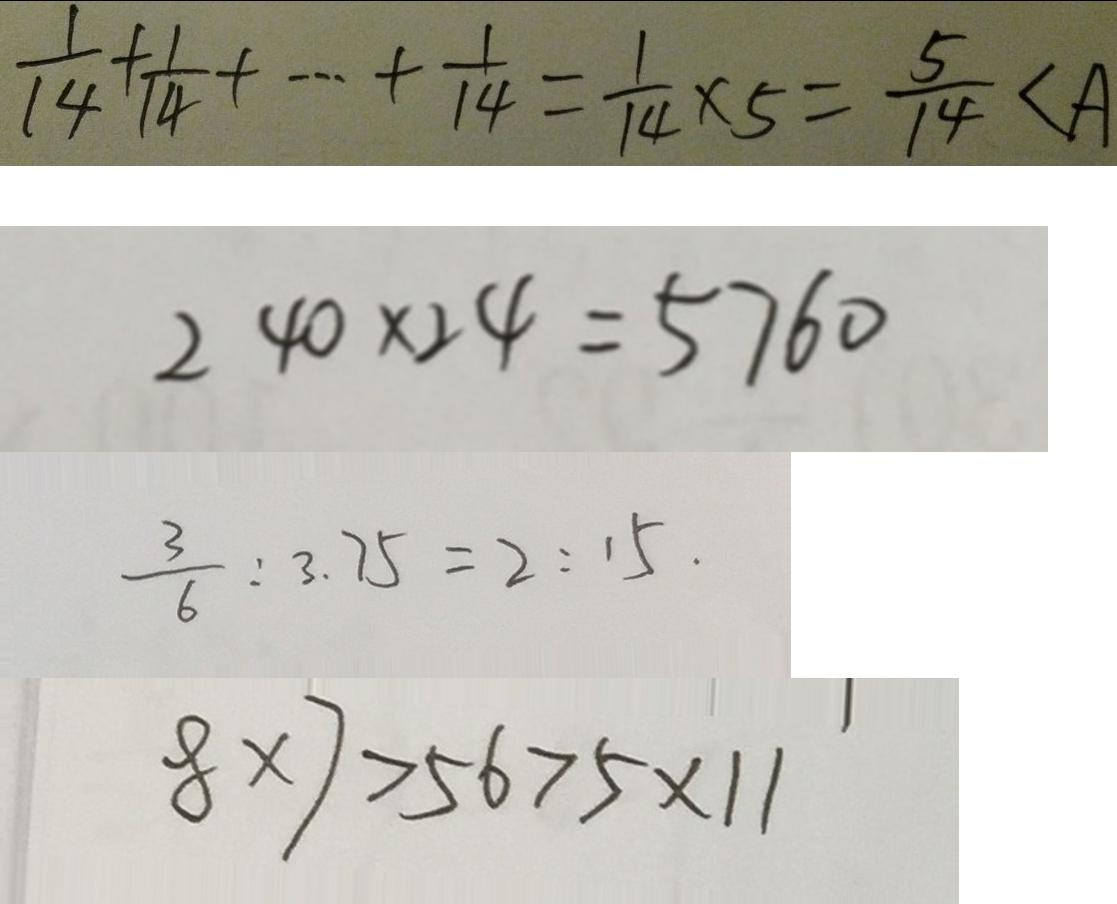<formula> <loc_0><loc_0><loc_500><loc_500>\frac { 1 } { 1 4 } + \frac { 1 } { 1 4 } + \cdots + \frac { 1 } { 1 4 } = \frac { 1 } { 1 4 } \times 5 = \frac { 5 } { 1 4 } < A 
 2 4 0 \times 2 4 = 5 7 6 0 
 \frac { 3 } { 6 } : 3 . 7 5 = 2 : 1 5 . 
 8 \times 7 > 5 6 > 5 \times 1 1</formula> 